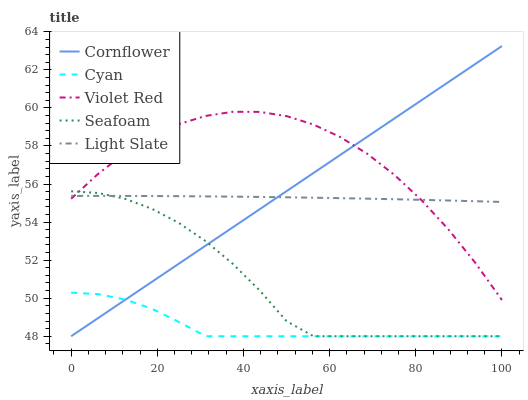Does Cornflower have the minimum area under the curve?
Answer yes or no. No. Does Cornflower have the maximum area under the curve?
Answer yes or no. No. Is Violet Red the smoothest?
Answer yes or no. No. Is Cornflower the roughest?
Answer yes or no. No. Does Violet Red have the lowest value?
Answer yes or no. No. Does Violet Red have the highest value?
Answer yes or no. No. Is Cyan less than Violet Red?
Answer yes or no. Yes. Is Violet Red greater than Cyan?
Answer yes or no. Yes. Does Cyan intersect Violet Red?
Answer yes or no. No. 